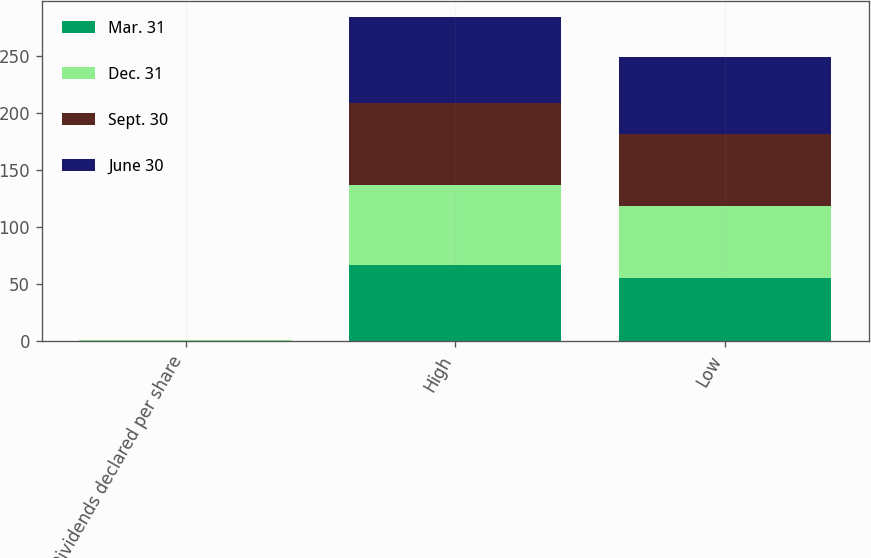<chart> <loc_0><loc_0><loc_500><loc_500><stacked_bar_chart><ecel><fcel>Dividends declared per share<fcel>High<fcel>Low<nl><fcel>Mar. 31<fcel>0.27<fcel>66.92<fcel>55.24<nl><fcel>Dec. 31<fcel>0.27<fcel>70<fcel>63.35<nl><fcel>Sept. 30<fcel>0.27<fcel>71.94<fcel>63.71<nl><fcel>June 30<fcel>0.3<fcel>75.55<fcel>66.93<nl></chart> 